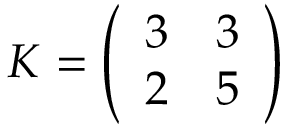Convert formula to latex. <formula><loc_0><loc_0><loc_500><loc_500>K = { \left ( \begin{array} { l l } { 3 } & { 3 } \\ { 2 } & { 5 } \end{array} \right ) }</formula> 